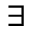Convert formula to latex. <formula><loc_0><loc_0><loc_500><loc_500>\exists</formula> 